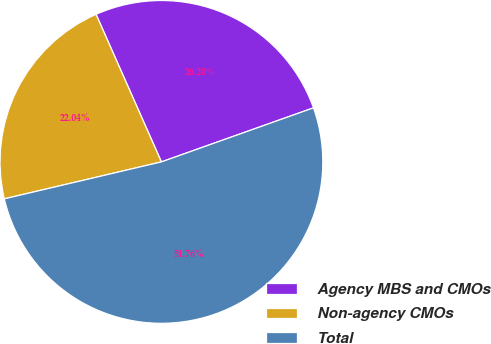Convert chart to OTSL. <chart><loc_0><loc_0><loc_500><loc_500><pie_chart><fcel>Agency MBS and CMOs<fcel>Non-agency CMOs<fcel>Total<nl><fcel>26.2%<fcel>22.04%<fcel>51.76%<nl></chart> 